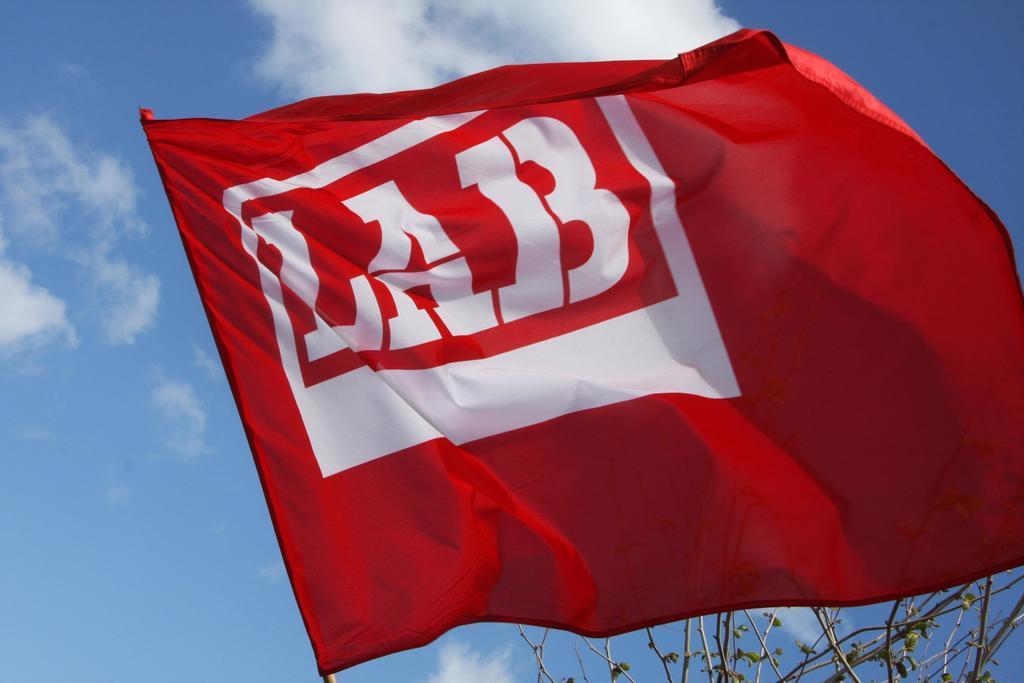In one or two sentences, can you explain what this image depicts? There is a white color text having white color border on a red color flag. In the background, there is a tree and there are clouds in the blue sky. 